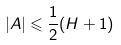<formula> <loc_0><loc_0><loc_500><loc_500>| A | \leqslant \frac { 1 } { 2 } ( H + 1 )</formula> 